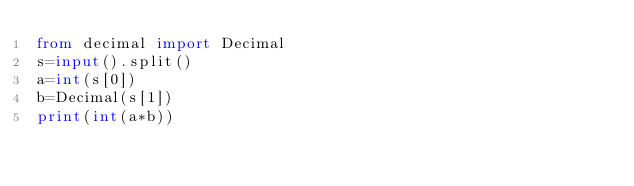Convert code to text. <code><loc_0><loc_0><loc_500><loc_500><_Python_>from decimal import Decimal
s=input().split()
a=int(s[0])
b=Decimal(s[1])
print(int(a*b))</code> 